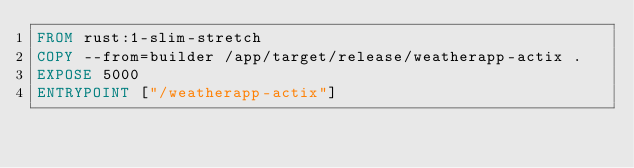<code> <loc_0><loc_0><loc_500><loc_500><_Dockerfile_>FROM rust:1-slim-stretch
COPY --from=builder /app/target/release/weatherapp-actix .
EXPOSE 5000
ENTRYPOINT ["/weatherapp-actix"]</code> 